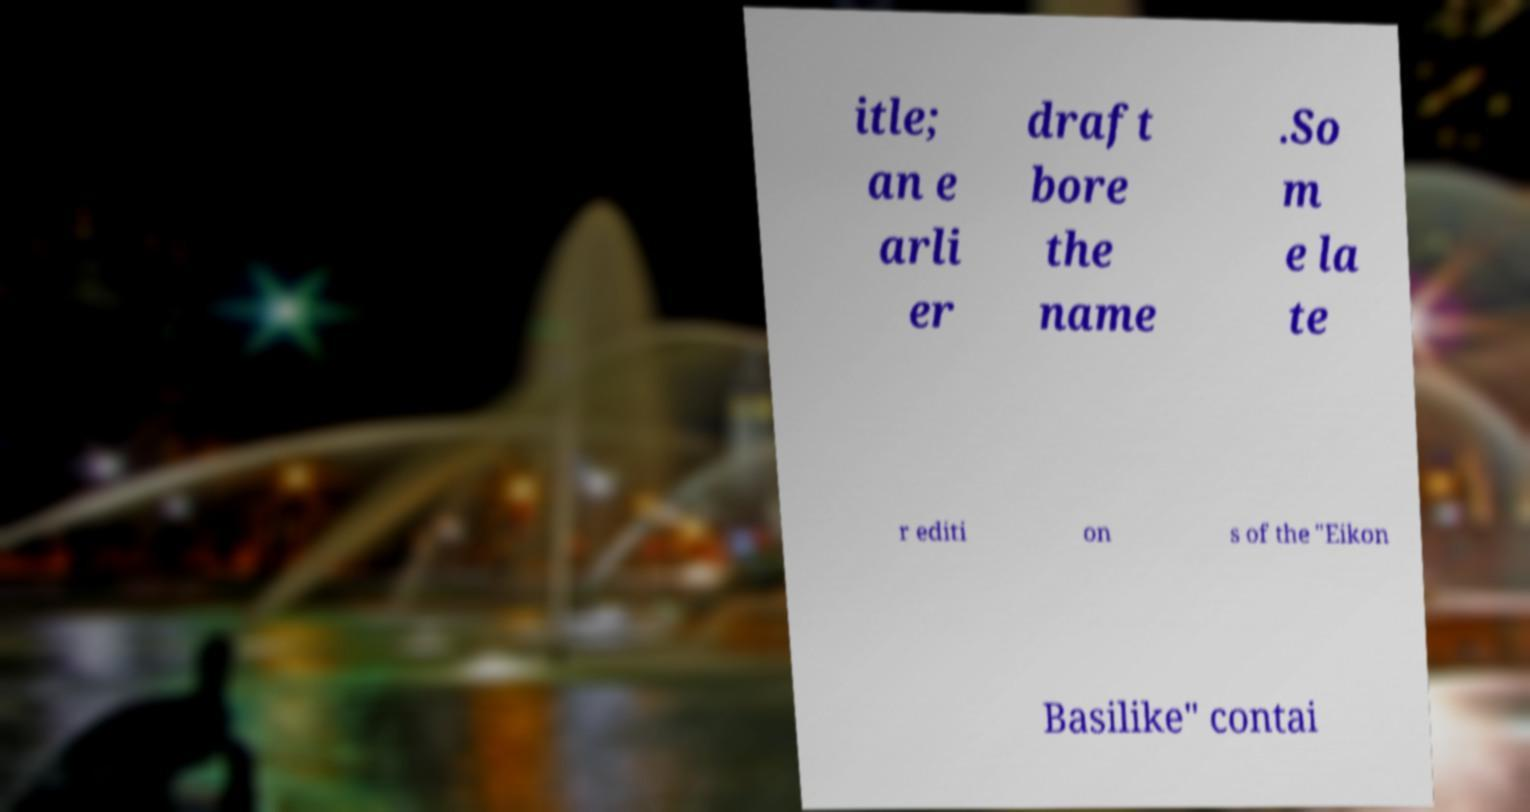Could you assist in decoding the text presented in this image and type it out clearly? itle; an e arli er draft bore the name .So m e la te r editi on s of the "Eikon Basilike" contai 